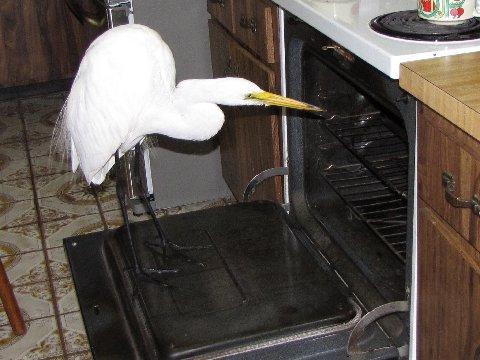Is this animal cooking?
Give a very brief answer. No. Which animal is this?
Be succinct. Pelican. What kind of oven is in this picture?
Quick response, please. Electric. Will the bird stay perched there for a long time?
Concise answer only. No. 